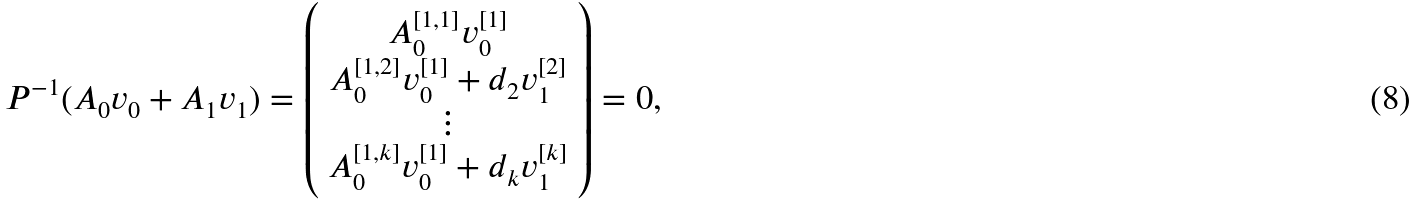<formula> <loc_0><loc_0><loc_500><loc_500>P ^ { - 1 } ( A _ { 0 } v _ { 0 } + A _ { 1 } v _ { 1 } ) = \left ( \begin{array} { c } A _ { 0 } ^ { [ 1 , 1 ] } v _ { 0 } ^ { [ 1 ] } \\ A _ { 0 } ^ { [ 1 , 2 ] } v _ { 0 } ^ { [ 1 ] } + d _ { 2 } v _ { 1 } ^ { [ 2 ] } \\ \vdots \\ A _ { 0 } ^ { [ 1 , k ] } v _ { 0 } ^ { [ 1 ] } + d _ { k } v _ { 1 } ^ { [ k ] } \end{array} \right ) = 0 ,</formula> 